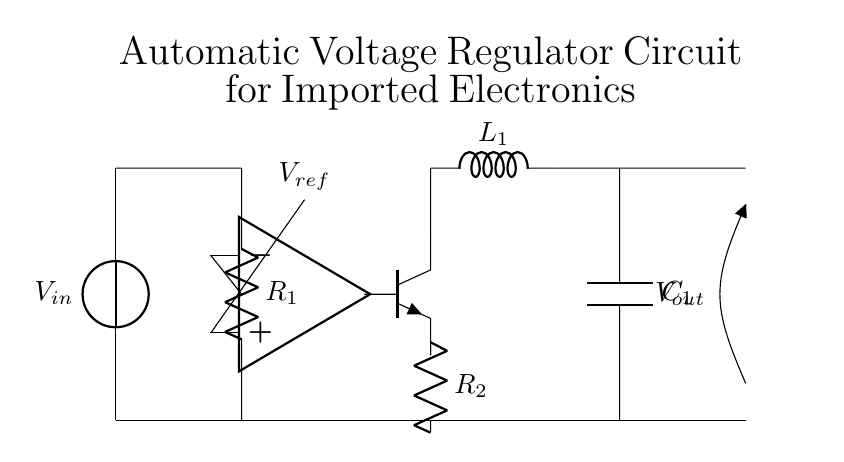What is the main function of the voltage sensor in this circuit? The voltage sensor measures the input voltage across R1 to ensure it is within acceptable limits. If the voltage is too high or low, the comparator adjusts the output to regulate the voltage.
Answer: Measure input voltage What type of transistor is used in the circuit? The circuit diagram indicates that there is an npn transistor, which is a type of bipolar junction transistor used to regulate current flow based on the comparator's output.
Answer: NPN What component provides the reference voltage for the comparator? In the circuit, the node labeled V_ref is where the reference voltage is set to compare against the input voltage from R1, allowing the comparator to determine if regulation is necessary.
Answer: V_ref How does the output capacitor affect the circuit's performance? The output capacitor (C1) smooths the output voltage by filtering out fluctuations and providing a stable voltage level to the load, which is crucial for sensitive electronics.
Answer: Smoothing output voltage What does the inductor L1 do in this circuit? In this circuit, the inductor (L1) helps to filter the output voltage, reducing high-frequency noise and stabilizing the voltage supplied to the load.
Answer: Filters output voltage What is the role of the comparator in the voltage regulation circuit? The comparator compares the input voltage (via R1) with the reference voltage (V_ref) and controls the transistor that regulates the output voltage by switching it on or off depending on the measured voltage.
Answer: Compare input voltage 